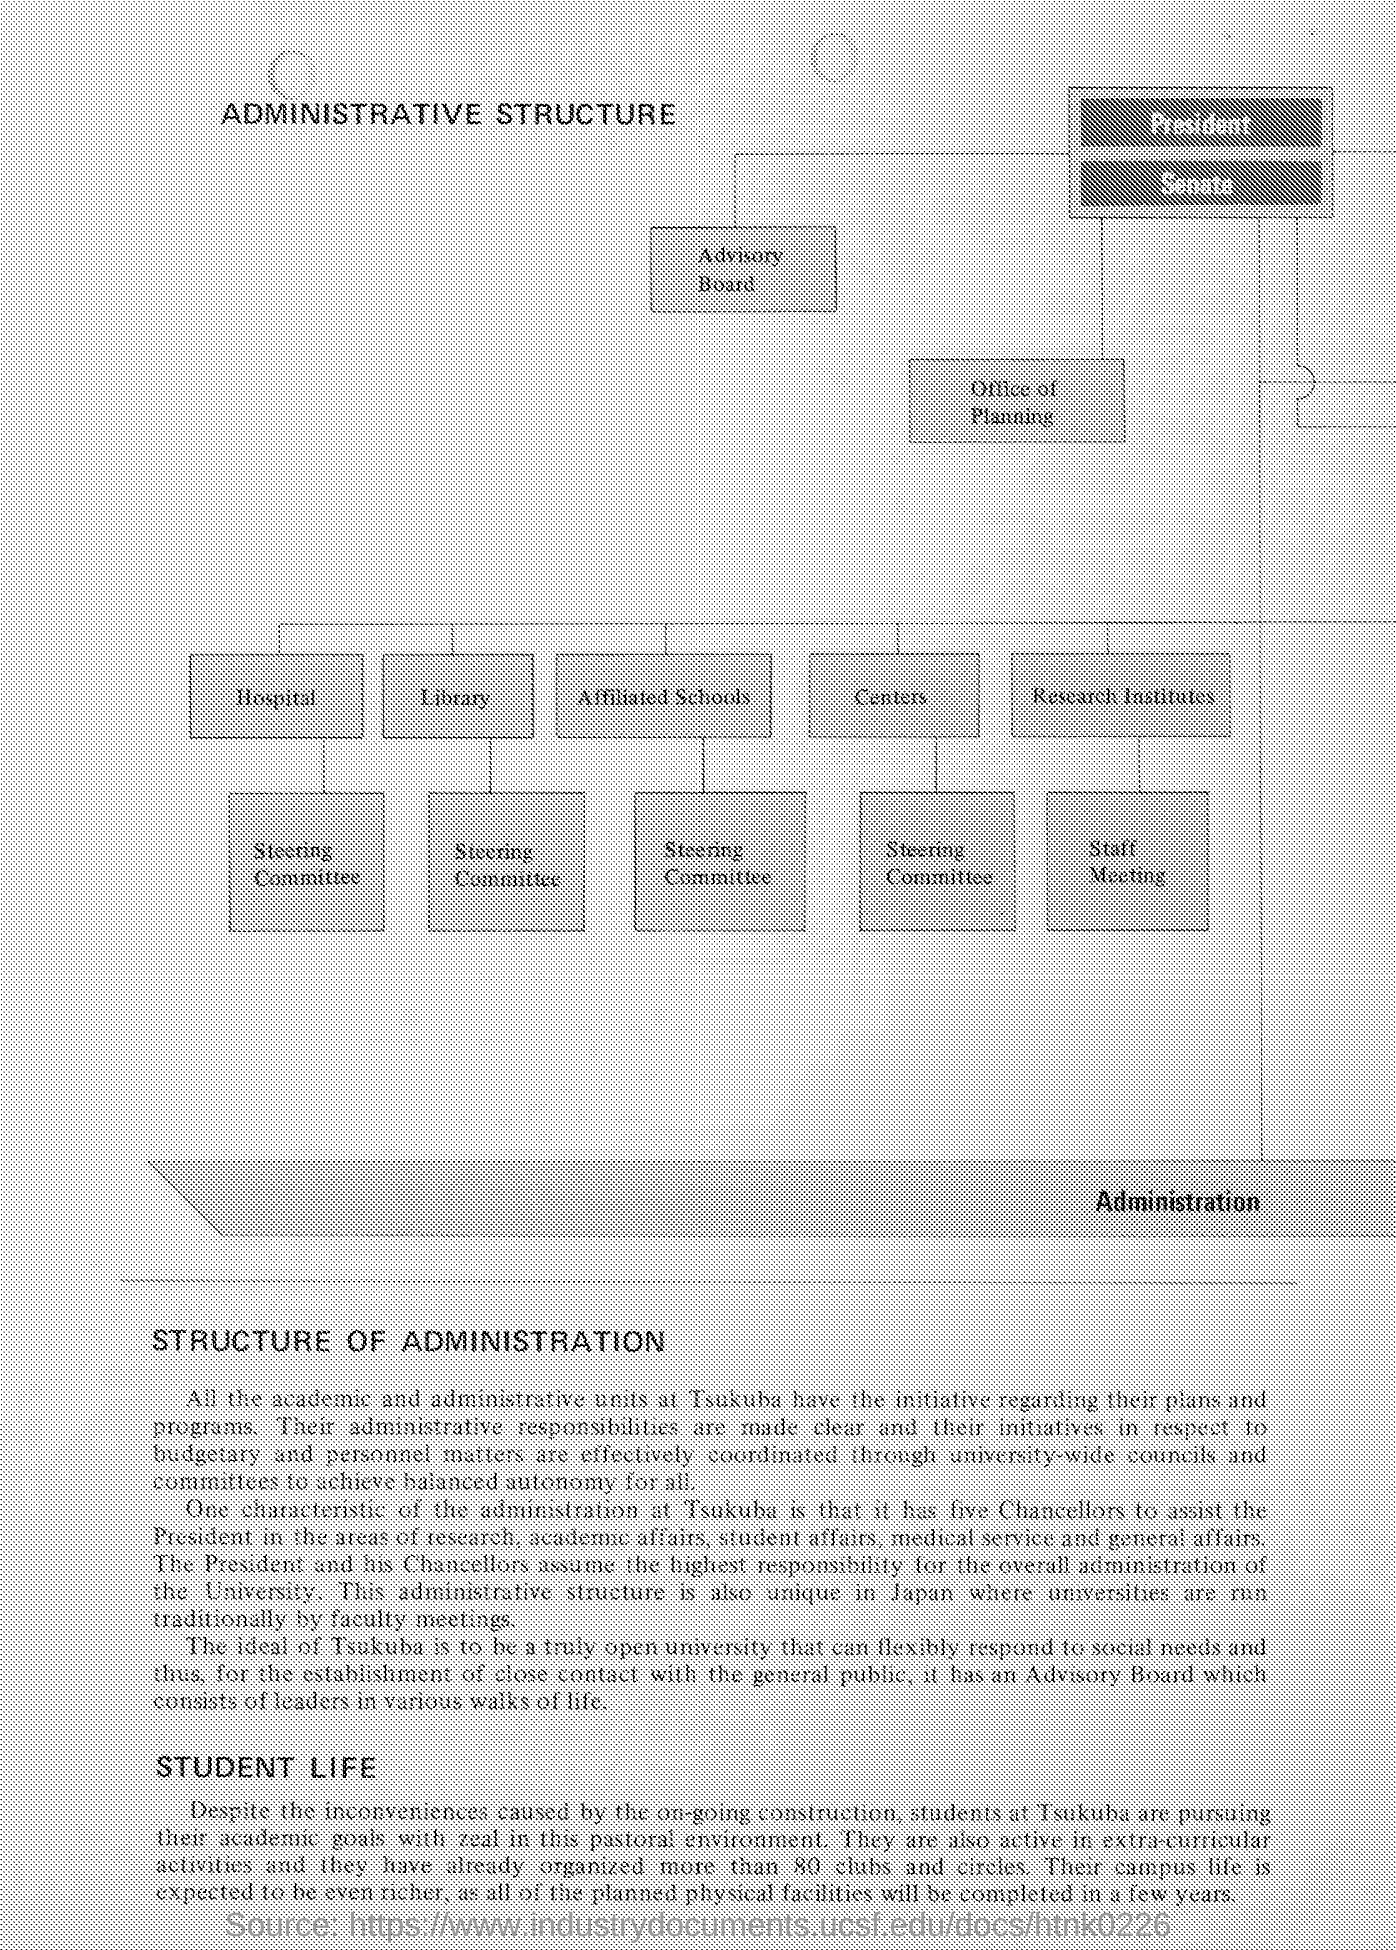Mention a couple of crucial points in this snapshot. The document's heading is "Administrative Structure". The source of the document located at <https://www.industrydocuments.ucsf.edu/docs/htnk0226..> is unknown. The President and his Chancellors assume the highest responsibility for the overall administration of the university. The flow diagram continues with 'Research Institutes,' followed by 'Staff Meeting.' There are five chancellors who assist the president. 